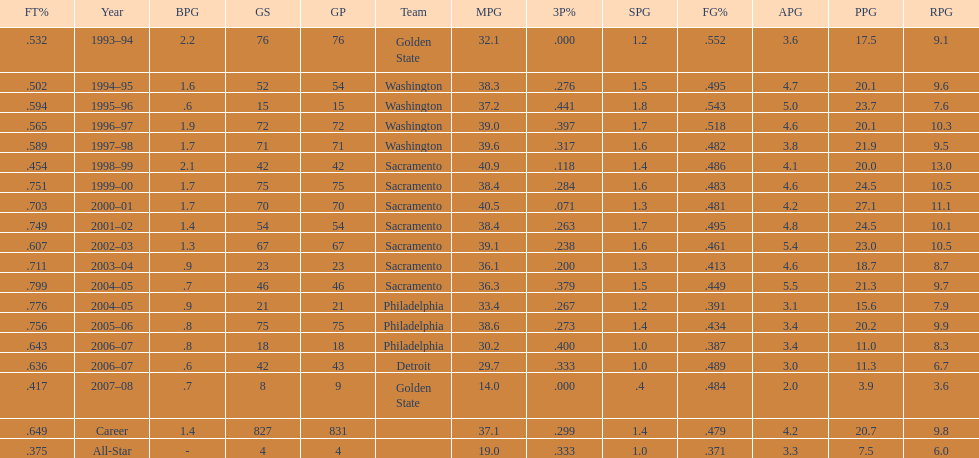How many seasons did webber average over 20 points per game (ppg)? 11. 